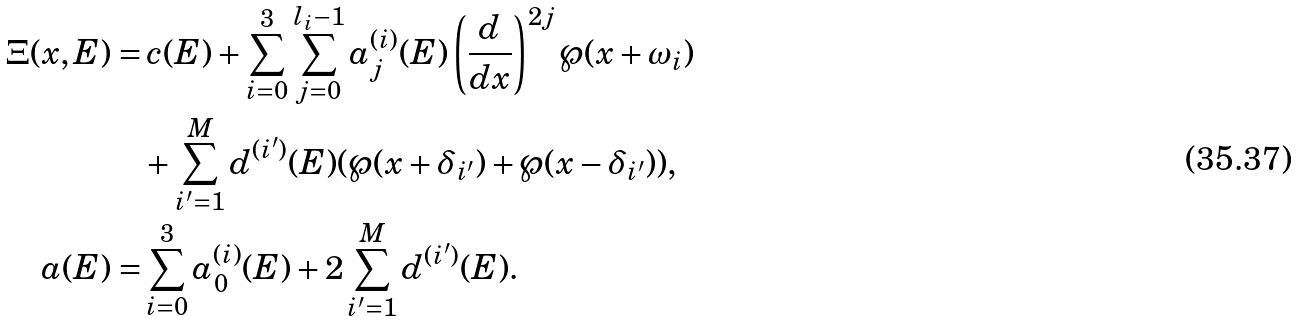<formula> <loc_0><loc_0><loc_500><loc_500>\Xi ( x , E ) = & \, c ( E ) + \sum _ { i = 0 } ^ { 3 } \sum _ { j = 0 } ^ { l _ { i } - 1 } a ^ { ( i ) } _ { j } ( E ) \left ( \frac { d } { d x } \right ) ^ { 2 j } \wp ( x + \omega _ { i } ) \\ & + \sum _ { i ^ { \prime } = 1 } ^ { M } d ^ { ( i ^ { \prime } ) } ( E ) ( \wp ( x + \delta _ { i ^ { \prime } } ) + \wp ( x - \delta _ { i ^ { \prime } } ) ) , \\ a ( E ) = & \sum _ { i = 0 } ^ { 3 } a ^ { ( i ) } _ { 0 } ( E ) + 2 \sum _ { i ^ { \prime } = 1 } ^ { M } d ^ { ( i ^ { \prime } ) } ( E ) .</formula> 